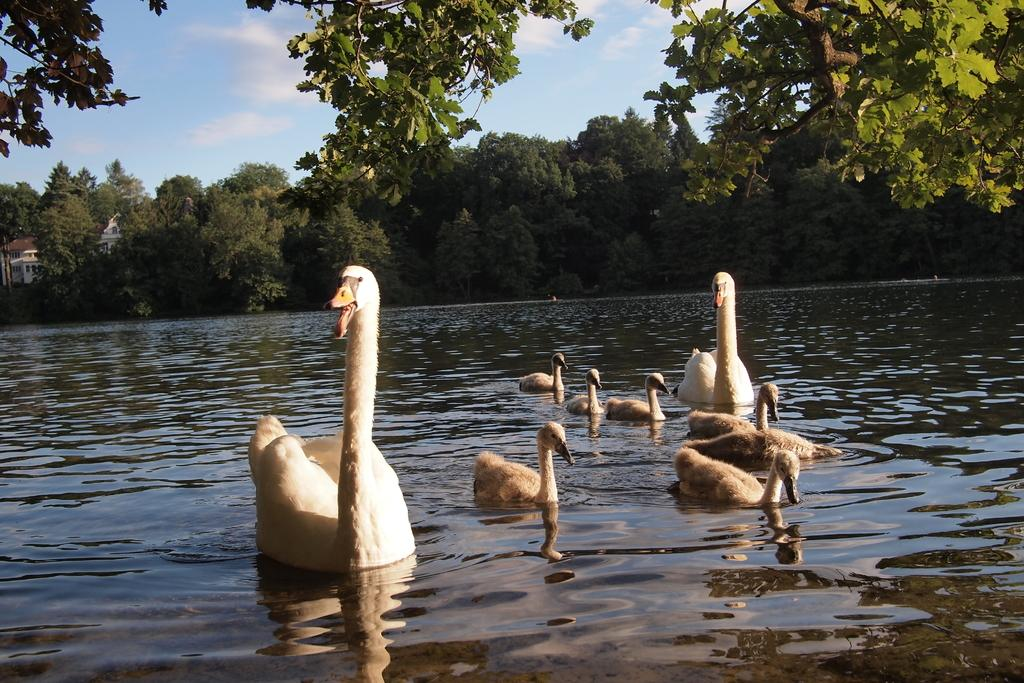What animals can be seen in the water in the image? There are swans in the water. What type of vegetation can be seen in the background of the image? There are trees in the background. What is visible in the sky at the top of the image? There are clouds visible in the sky. What type of advertisement can be seen on the swan's back in the image? There is no advertisement present on the swan's back in the image. What event is taking place in the image? There is no specific event depicted in the image; it simply shows swans in the water with trees and clouds in the background. 